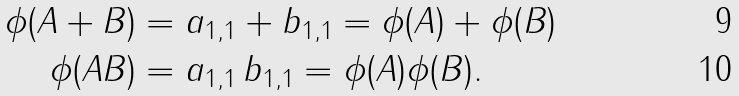<formula> <loc_0><loc_0><loc_500><loc_500>\phi ( A + B ) & = a _ { 1 , 1 } + b _ { 1 , 1 } = \phi ( A ) + \phi ( B ) \\ \phi ( A B ) & = a _ { 1 , 1 } \, b _ { 1 , 1 } = \phi ( A ) \phi ( B ) .</formula> 